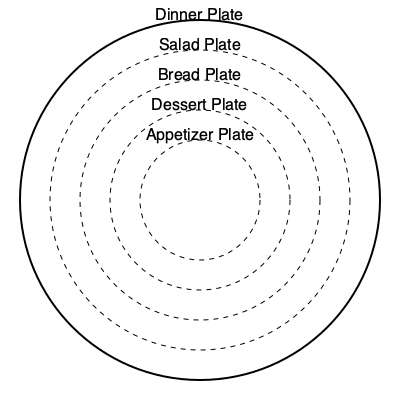As an aspiring chef planning a gourmet dinner party, you're arranging plates on a circular dining table. The table has a diameter of 180 cm, and you have 5 different types of plates: dinner plates (60 cm diameter), salad plates (50 cm), bread plates (40 cm), dessert plates (30 cm), and appetizer plates (20 cm). If you want to maximize the number of place settings while ensuring each setting has all 5 plate types, how many complete place settings can you fit around the table? Let's approach this step-by-step:

1) First, we need to calculate the circumference of the table:
   $C = \pi d = \pi \times 180 \approx 565.49$ cm

2) Now, we need to determine how much space each place setting requires. Each setting includes all 5 plates side by side:
   $60 + 50 + 40 + 30 + 20 = 200$ cm

3) However, we can't simply divide the circumference by 200 cm, as the plates are circular and can be arranged more efficiently.

4) The most efficient arrangement would be to place the largest plate (dinner plate) first, then nest the smaller plates inside its circumference.

5) In this arrangement, each place setting would effectively occupy the width of the dinner plate (60 cm) plus a small gap (let's assume 5 cm) for ease of use:
   $60 + 5 = 65$ cm per setting

6) Now we can calculate the maximum number of settings:
   $\frac{565.49}{65} \approx 8.7$

7) Since we can't have a fraction of a place setting, we round down to 8.

Therefore, you can fit 8 complete place settings around the table.
Answer: 8 place settings 